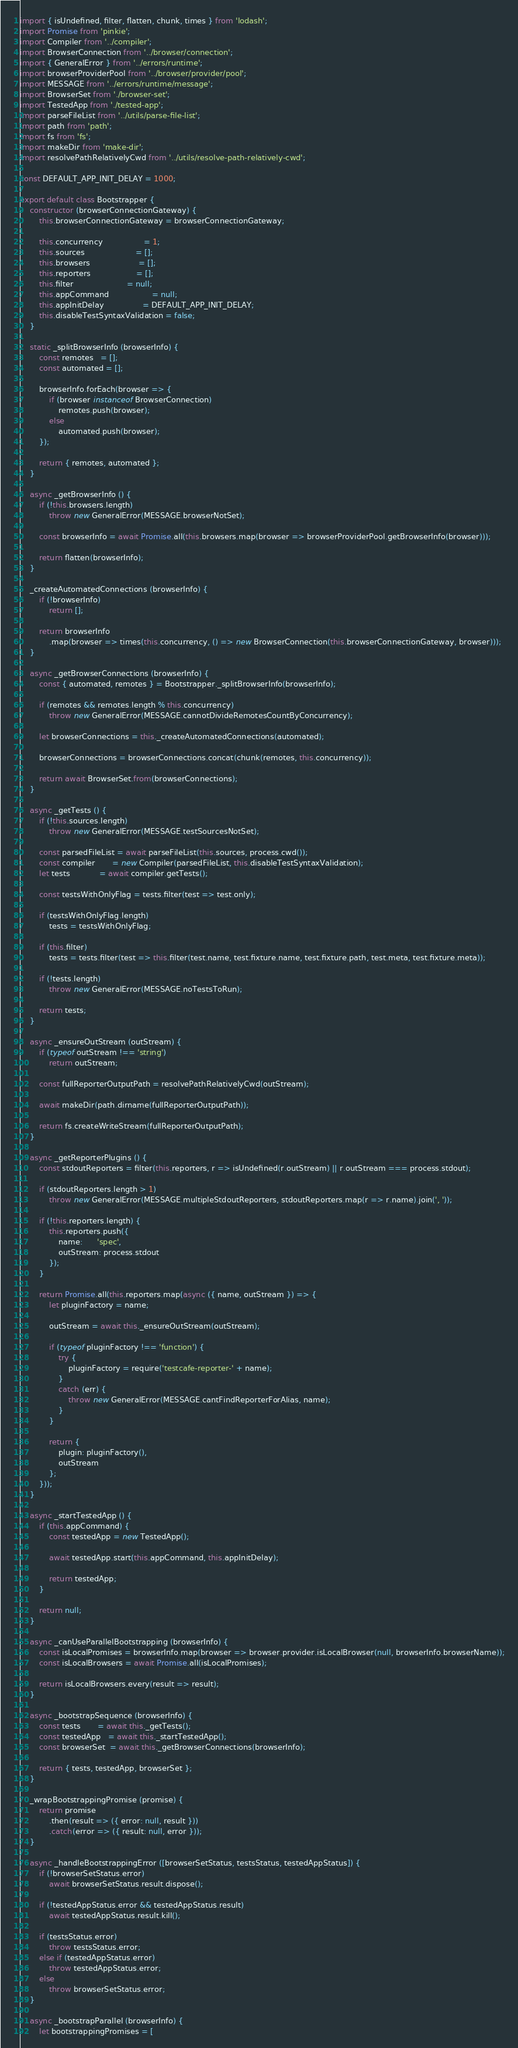Convert code to text. <code><loc_0><loc_0><loc_500><loc_500><_JavaScript_>import { isUndefined, filter, flatten, chunk, times } from 'lodash';
import Promise from 'pinkie';
import Compiler from '../compiler';
import BrowserConnection from '../browser/connection';
import { GeneralError } from '../errors/runtime';
import browserProviderPool from '../browser/provider/pool';
import MESSAGE from '../errors/runtime/message';
import BrowserSet from './browser-set';
import TestedApp from './tested-app';
import parseFileList from '../utils/parse-file-list';
import path from 'path';
import fs from 'fs';
import makeDir from 'make-dir';
import resolvePathRelativelyCwd from '../utils/resolve-path-relatively-cwd';

const DEFAULT_APP_INIT_DELAY = 1000;

export default class Bootstrapper {
    constructor (browserConnectionGateway) {
        this.browserConnectionGateway = browserConnectionGateway;

        this.concurrency                 = 1;
        this.sources                     = [];
        this.browsers                    = [];
        this.reporters                   = [];
        this.filter                      = null;
        this.appCommand                  = null;
        this.appInitDelay                = DEFAULT_APP_INIT_DELAY;
        this.disableTestSyntaxValidation = false;
    }

    static _splitBrowserInfo (browserInfo) {
        const remotes   = [];
        const automated = [];

        browserInfo.forEach(browser => {
            if (browser instanceof BrowserConnection)
                remotes.push(browser);
            else
                automated.push(browser);
        });

        return { remotes, automated };
    }

    async _getBrowserInfo () {
        if (!this.browsers.length)
            throw new GeneralError(MESSAGE.browserNotSet);

        const browserInfo = await Promise.all(this.browsers.map(browser => browserProviderPool.getBrowserInfo(browser)));

        return flatten(browserInfo);
    }

    _createAutomatedConnections (browserInfo) {
        if (!browserInfo)
            return [];

        return browserInfo
            .map(browser => times(this.concurrency, () => new BrowserConnection(this.browserConnectionGateway, browser)));
    }

    async _getBrowserConnections (browserInfo) {
        const { automated, remotes } = Bootstrapper._splitBrowserInfo(browserInfo);

        if (remotes && remotes.length % this.concurrency)
            throw new GeneralError(MESSAGE.cannotDivideRemotesCountByConcurrency);

        let browserConnections = this._createAutomatedConnections(automated);

        browserConnections = browserConnections.concat(chunk(remotes, this.concurrency));

        return await BrowserSet.from(browserConnections);
    }

    async _getTests () {
        if (!this.sources.length)
            throw new GeneralError(MESSAGE.testSourcesNotSet);

        const parsedFileList = await parseFileList(this.sources, process.cwd());
        const compiler       = new Compiler(parsedFileList, this.disableTestSyntaxValidation);
        let tests            = await compiler.getTests();

        const testsWithOnlyFlag = tests.filter(test => test.only);

        if (testsWithOnlyFlag.length)
            tests = testsWithOnlyFlag;

        if (this.filter)
            tests = tests.filter(test => this.filter(test.name, test.fixture.name, test.fixture.path, test.meta, test.fixture.meta));

        if (!tests.length)
            throw new GeneralError(MESSAGE.noTestsToRun);

        return tests;
    }

    async _ensureOutStream (outStream) {
        if (typeof outStream !== 'string')
            return outStream;

        const fullReporterOutputPath = resolvePathRelativelyCwd(outStream);

        await makeDir(path.dirname(fullReporterOutputPath));

        return fs.createWriteStream(fullReporterOutputPath);
    }

    async _getReporterPlugins () {
        const stdoutReporters = filter(this.reporters, r => isUndefined(r.outStream) || r.outStream === process.stdout);

        if (stdoutReporters.length > 1)
            throw new GeneralError(MESSAGE.multipleStdoutReporters, stdoutReporters.map(r => r.name).join(', '));

        if (!this.reporters.length) {
            this.reporters.push({
                name:      'spec',
                outStream: process.stdout
            });
        }

        return Promise.all(this.reporters.map(async ({ name, outStream }) => {
            let pluginFactory = name;

            outStream = await this._ensureOutStream(outStream);

            if (typeof pluginFactory !== 'function') {
                try {
                    pluginFactory = require('testcafe-reporter-' + name);
                }
                catch (err) {
                    throw new GeneralError(MESSAGE.cantFindReporterForAlias, name);
                }
            }

            return {
                plugin: pluginFactory(),
                outStream
            };
        }));
    }

    async _startTestedApp () {
        if (this.appCommand) {
            const testedApp = new TestedApp();

            await testedApp.start(this.appCommand, this.appInitDelay);

            return testedApp;
        }

        return null;
    }

    async _canUseParallelBootstrapping (browserInfo) {
        const isLocalPromises = browserInfo.map(browser => browser.provider.isLocalBrowser(null, browserInfo.browserName));
        const isLocalBrowsers = await Promise.all(isLocalPromises);

        return isLocalBrowsers.every(result => result);
    }

    async _bootstrapSequence (browserInfo) {
        const tests       = await this._getTests();
        const testedApp   = await this._startTestedApp();
        const browserSet  = await this._getBrowserConnections(browserInfo);

        return { tests, testedApp, browserSet };
    }

    _wrapBootstrappingPromise (promise) {
        return promise
            .then(result => ({ error: null, result }))
            .catch(error => ({ result: null, error }));
    }

    async _handleBootstrappingError ([browserSetStatus, testsStatus, testedAppStatus]) {
        if (!browserSetStatus.error)
            await browserSetStatus.result.dispose();

        if (!testedAppStatus.error && testedAppStatus.result)
            await testedAppStatus.result.kill();

        if (testsStatus.error)
            throw testsStatus.error;
        else if (testedAppStatus.error)
            throw testedAppStatus.error;
        else
            throw browserSetStatus.error;
    }

    async _bootstrapParallel (browserInfo) {
        let bootstrappingPromises = [</code> 